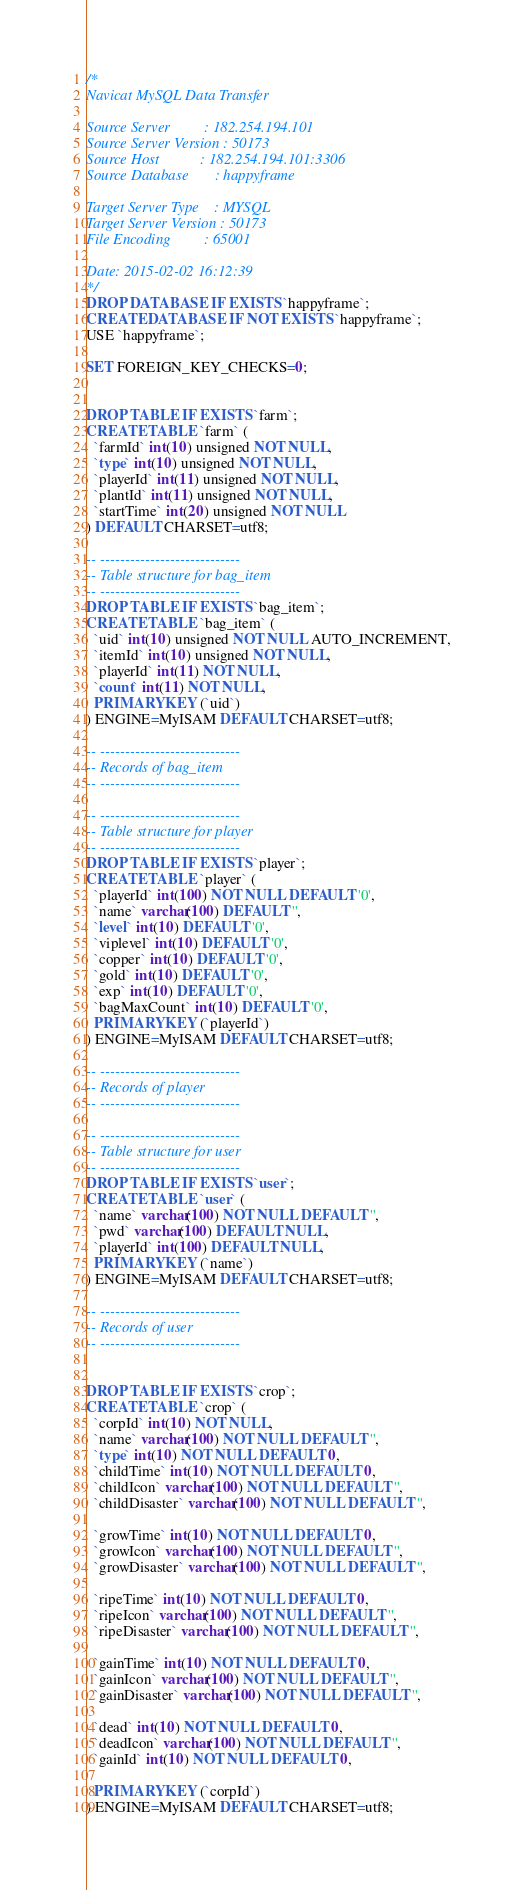Convert code to text. <code><loc_0><loc_0><loc_500><loc_500><_SQL_>/*
Navicat MySQL Data Transfer

Source Server         : 182.254.194.101
Source Server Version : 50173
Source Host           : 182.254.194.101:3306
Source Database       : happyframe

Target Server Type    : MYSQL
Target Server Version : 50173
File Encoding         : 65001

Date: 2015-02-02 16:12:39
*/
DROP DATABASE IF EXISTS `happyframe`;
CREATE DATABASE IF NOT EXISTS `happyframe`;
USE `happyframe`;

SET FOREIGN_KEY_CHECKS=0;


DROP TABLE IF EXISTS `farm`;
CREATE TABLE `farm` (
  `farmId` int(10) unsigned NOT NULL,
  `type` int(10) unsigned NOT NULL,
  `playerId` int(11) unsigned NOT NULL,
  `plantId` int(11) unsigned NOT NULL,
  `startTime` int(20) unsigned NOT NULL
) DEFAULT CHARSET=utf8;

-- ----------------------------
-- Table structure for bag_item
-- ----------------------------
DROP TABLE IF EXISTS `bag_item`;
CREATE TABLE `bag_item` (
  `uid` int(10) unsigned NOT NULL AUTO_INCREMENT,
  `itemId` int(10) unsigned NOT NULL,
  `playerId` int(11) NOT NULL,
  `count` int(11) NOT NULL,
  PRIMARY KEY (`uid`)
) ENGINE=MyISAM DEFAULT CHARSET=utf8;

-- ----------------------------
-- Records of bag_item
-- ----------------------------

-- ----------------------------
-- Table structure for player
-- ----------------------------
DROP TABLE IF EXISTS `player`;
CREATE TABLE `player` (
  `playerId` int(100) NOT NULL DEFAULT '0',
  `name` varchar(100) DEFAULT '',
  `level` int(10) DEFAULT '0',
  `viplevel` int(10) DEFAULT '0',
  `copper` int(10) DEFAULT '0',
  `gold` int(10) DEFAULT '0',
  `exp` int(10) DEFAULT '0',
  `bagMaxCount` int(10) DEFAULT '0',
  PRIMARY KEY (`playerId`)
) ENGINE=MyISAM DEFAULT CHARSET=utf8;

-- ----------------------------
-- Records of player
-- ----------------------------

-- ----------------------------
-- Table structure for user
-- ----------------------------
DROP TABLE IF EXISTS `user`;
CREATE TABLE `user` (
  `name` varchar(100) NOT NULL DEFAULT '',
  `pwd` varchar(100) DEFAULT NULL,
  `playerId` int(100) DEFAULT NULL,
  PRIMARY KEY (`name`)
) ENGINE=MyISAM DEFAULT CHARSET=utf8;

-- ----------------------------
-- Records of user
-- ----------------------------


DROP TABLE IF EXISTS `crop`;
CREATE TABLE `crop` (
  `corpId` int(10) NOT NULL,
  `name` varchar(100) NOT NULL DEFAULT '',
  `type` int(10) NOT NULL DEFAULT 0,
  `childTime` int(10) NOT NULL DEFAULT 0,
  `childIcon` varchar(100) NOT NULL DEFAULT '',
  `childDisaster` varchar(100) NOT NULL DEFAULT '',
  
  `growTime` int(10) NOT NULL DEFAULT 0,
  `growIcon` varchar(100) NOT NULL DEFAULT '',
  `growDisaster` varchar(100) NOT NULL DEFAULT '',
  
  `ripeTime` int(10) NOT NULL DEFAULT 0,
  `ripeIcon` varchar(100) NOT NULL DEFAULT '',
  `ripeDisaster` varchar(100) NOT NULL DEFAULT '',
  
  `gainTime` int(10) NOT NULL DEFAULT 0,
  `gainIcon` varchar(100) NOT NULL DEFAULT '',
  `gainDisaster` varchar(100) NOT NULL DEFAULT '',

  `dead` int(10) NOT NULL DEFAULT 0,
  `deadIcon` varchar(100) NOT NULL DEFAULT '',
  `gainId` int(10) NOT NULL DEFAULT 0,
  
  PRIMARY KEY (`corpId`)
) ENGINE=MyISAM DEFAULT CHARSET=utf8;





</code> 